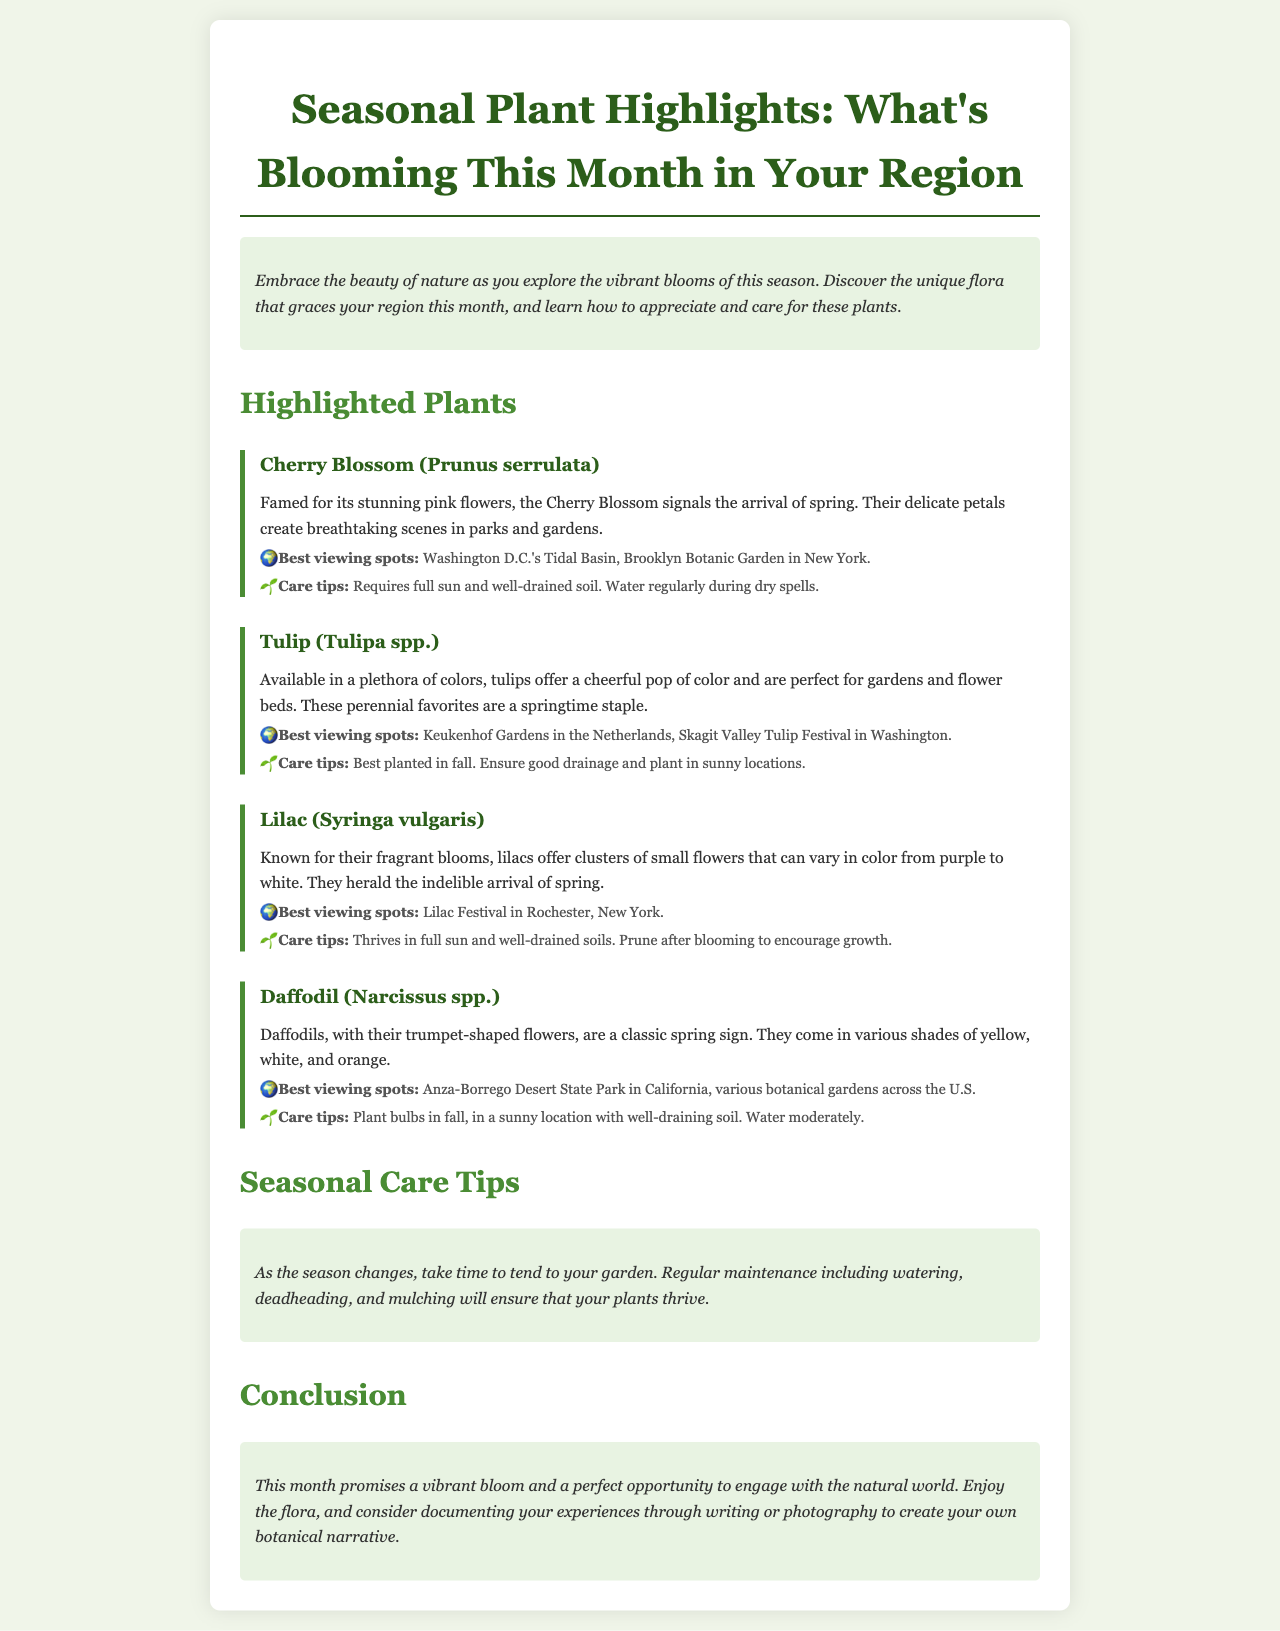What is the title of the brochure? The title is presented prominently at the top of the document in a large font.
Answer: Seasonal Plant Highlights: What's Blooming This Month in Your Region What type of plant is known for its stunning pink flowers? This information is found in the section detailing highlighted plants, specifically noting their characteristics.
Answer: Cherry Blossom Where is the best viewing spot for Tulips? The document lists specific locations for viewing tulips, which are mentioned in the description of the plant.
Answer: Keukenhof Gardens in the Netherlands What is a care tip for Daffodils? The care tips for daffodils are included under their section, providing specific gardening advice.
Answer: Plant bulbs in fall What plant is associated with fragrances and clusters of flowers? This question connects to the description of a specific highlighted plant known for its scent.
Answer: Lilac What seasonal activity is recommended in the care tips section? The document suggests specific gardening tasks to ensure the health of plants during the changing season.
Answer: Regular maintenance Which festival is mentioned for Lilacs? The document includes a specific event related to lilacs, noted under the plant's viewing spots.
Answer: Lilac Festival in Rochester, New York What color options do Tulips come in? The document specifies the variety of colors available for tulips under their description.
Answer: A plethora of colors 